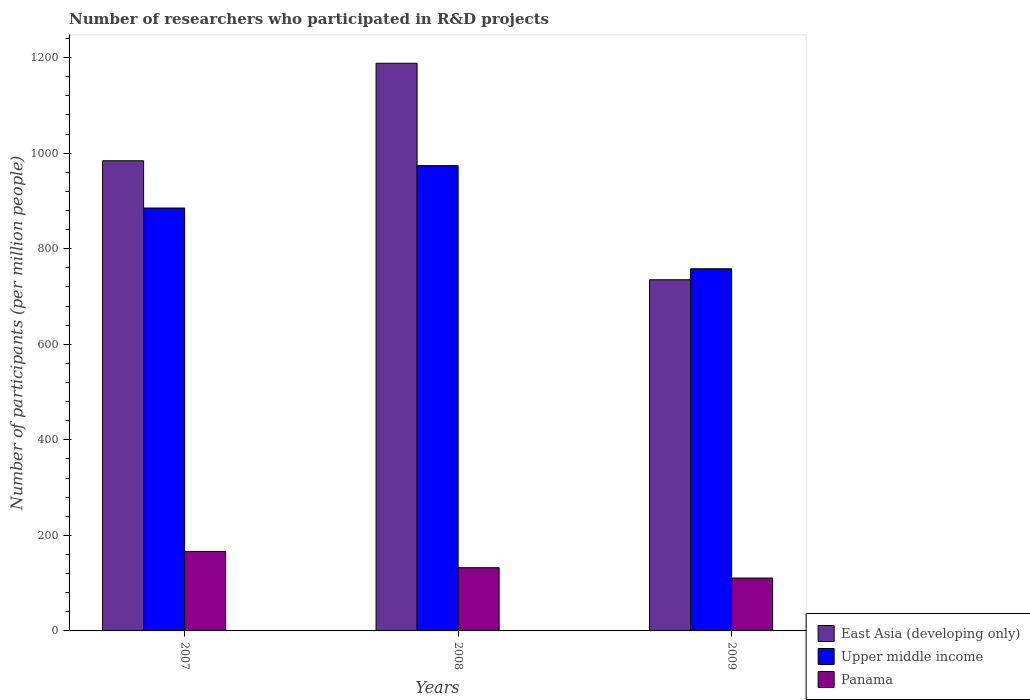How many different coloured bars are there?
Provide a succinct answer. 3. Are the number of bars per tick equal to the number of legend labels?
Your answer should be compact. Yes. Are the number of bars on each tick of the X-axis equal?
Make the answer very short. Yes. What is the label of the 3rd group of bars from the left?
Offer a very short reply. 2009. In how many cases, is the number of bars for a given year not equal to the number of legend labels?
Ensure brevity in your answer.  0. What is the number of researchers who participated in R&D projects in Panama in 2007?
Offer a very short reply. 166.36. Across all years, what is the maximum number of researchers who participated in R&D projects in Panama?
Your response must be concise. 166.36. Across all years, what is the minimum number of researchers who participated in R&D projects in Upper middle income?
Provide a short and direct response. 758.08. What is the total number of researchers who participated in R&D projects in Panama in the graph?
Provide a short and direct response. 409.38. What is the difference between the number of researchers who participated in R&D projects in East Asia (developing only) in 2007 and that in 2009?
Offer a very short reply. 249.1. What is the difference between the number of researchers who participated in R&D projects in East Asia (developing only) in 2007 and the number of researchers who participated in R&D projects in Panama in 2009?
Offer a very short reply. 873.46. What is the average number of researchers who participated in R&D projects in Panama per year?
Provide a short and direct response. 136.46. In the year 2008, what is the difference between the number of researchers who participated in R&D projects in East Asia (developing only) and number of researchers who participated in R&D projects in Panama?
Your response must be concise. 1055.9. In how many years, is the number of researchers who participated in R&D projects in East Asia (developing only) greater than 1200?
Your response must be concise. 0. What is the ratio of the number of researchers who participated in R&D projects in East Asia (developing only) in 2008 to that in 2009?
Your answer should be compact. 1.62. Is the number of researchers who participated in R&D projects in Upper middle income in 2007 less than that in 2008?
Offer a terse response. Yes. Is the difference between the number of researchers who participated in R&D projects in East Asia (developing only) in 2007 and 2008 greater than the difference between the number of researchers who participated in R&D projects in Panama in 2007 and 2008?
Ensure brevity in your answer.  No. What is the difference between the highest and the second highest number of researchers who participated in R&D projects in Panama?
Your answer should be compact. 34.02. What is the difference between the highest and the lowest number of researchers who participated in R&D projects in Panama?
Your response must be concise. 55.66. In how many years, is the number of researchers who participated in R&D projects in Panama greater than the average number of researchers who participated in R&D projects in Panama taken over all years?
Ensure brevity in your answer.  1. What does the 1st bar from the left in 2007 represents?
Offer a terse response. East Asia (developing only). What does the 1st bar from the right in 2009 represents?
Make the answer very short. Panama. How many years are there in the graph?
Ensure brevity in your answer.  3. What is the difference between two consecutive major ticks on the Y-axis?
Offer a terse response. 200. Are the values on the major ticks of Y-axis written in scientific E-notation?
Your response must be concise. No. Does the graph contain any zero values?
Provide a succinct answer. No. Does the graph contain grids?
Your response must be concise. No. How are the legend labels stacked?
Keep it short and to the point. Vertical. What is the title of the graph?
Your response must be concise. Number of researchers who participated in R&D projects. Does "Fiji" appear as one of the legend labels in the graph?
Your answer should be very brief. No. What is the label or title of the X-axis?
Your answer should be very brief. Years. What is the label or title of the Y-axis?
Your answer should be compact. Number of participants (per million people). What is the Number of participants (per million people) of East Asia (developing only) in 2007?
Ensure brevity in your answer.  984.15. What is the Number of participants (per million people) in Upper middle income in 2007?
Give a very brief answer. 885.24. What is the Number of participants (per million people) in Panama in 2007?
Give a very brief answer. 166.36. What is the Number of participants (per million people) of East Asia (developing only) in 2008?
Your answer should be very brief. 1188.24. What is the Number of participants (per million people) of Upper middle income in 2008?
Provide a short and direct response. 973.96. What is the Number of participants (per million people) of Panama in 2008?
Your answer should be compact. 132.34. What is the Number of participants (per million people) in East Asia (developing only) in 2009?
Ensure brevity in your answer.  735.05. What is the Number of participants (per million people) of Upper middle income in 2009?
Your response must be concise. 758.08. What is the Number of participants (per million people) of Panama in 2009?
Make the answer very short. 110.69. Across all years, what is the maximum Number of participants (per million people) in East Asia (developing only)?
Your answer should be compact. 1188.24. Across all years, what is the maximum Number of participants (per million people) of Upper middle income?
Offer a terse response. 973.96. Across all years, what is the maximum Number of participants (per million people) of Panama?
Offer a terse response. 166.36. Across all years, what is the minimum Number of participants (per million people) in East Asia (developing only)?
Offer a terse response. 735.05. Across all years, what is the minimum Number of participants (per million people) in Upper middle income?
Provide a succinct answer. 758.08. Across all years, what is the minimum Number of participants (per million people) in Panama?
Provide a succinct answer. 110.69. What is the total Number of participants (per million people) in East Asia (developing only) in the graph?
Your answer should be very brief. 2907.43. What is the total Number of participants (per million people) in Upper middle income in the graph?
Ensure brevity in your answer.  2617.28. What is the total Number of participants (per million people) in Panama in the graph?
Provide a succinct answer. 409.38. What is the difference between the Number of participants (per million people) in East Asia (developing only) in 2007 and that in 2008?
Make the answer very short. -204.09. What is the difference between the Number of participants (per million people) of Upper middle income in 2007 and that in 2008?
Your answer should be very brief. -88.72. What is the difference between the Number of participants (per million people) of Panama in 2007 and that in 2008?
Keep it short and to the point. 34.02. What is the difference between the Number of participants (per million people) in East Asia (developing only) in 2007 and that in 2009?
Provide a short and direct response. 249.1. What is the difference between the Number of participants (per million people) in Upper middle income in 2007 and that in 2009?
Offer a very short reply. 127.16. What is the difference between the Number of participants (per million people) of Panama in 2007 and that in 2009?
Offer a very short reply. 55.66. What is the difference between the Number of participants (per million people) of East Asia (developing only) in 2008 and that in 2009?
Keep it short and to the point. 453.19. What is the difference between the Number of participants (per million people) in Upper middle income in 2008 and that in 2009?
Offer a very short reply. 215.88. What is the difference between the Number of participants (per million people) of Panama in 2008 and that in 2009?
Offer a terse response. 21.64. What is the difference between the Number of participants (per million people) of East Asia (developing only) in 2007 and the Number of participants (per million people) of Upper middle income in 2008?
Your answer should be very brief. 10.19. What is the difference between the Number of participants (per million people) of East Asia (developing only) in 2007 and the Number of participants (per million people) of Panama in 2008?
Your answer should be compact. 851.81. What is the difference between the Number of participants (per million people) of Upper middle income in 2007 and the Number of participants (per million people) of Panama in 2008?
Keep it short and to the point. 752.91. What is the difference between the Number of participants (per million people) of East Asia (developing only) in 2007 and the Number of participants (per million people) of Upper middle income in 2009?
Your response must be concise. 226.07. What is the difference between the Number of participants (per million people) in East Asia (developing only) in 2007 and the Number of participants (per million people) in Panama in 2009?
Keep it short and to the point. 873.46. What is the difference between the Number of participants (per million people) of Upper middle income in 2007 and the Number of participants (per million people) of Panama in 2009?
Provide a short and direct response. 774.55. What is the difference between the Number of participants (per million people) of East Asia (developing only) in 2008 and the Number of participants (per million people) of Upper middle income in 2009?
Offer a very short reply. 430.16. What is the difference between the Number of participants (per million people) of East Asia (developing only) in 2008 and the Number of participants (per million people) of Panama in 2009?
Keep it short and to the point. 1077.54. What is the difference between the Number of participants (per million people) in Upper middle income in 2008 and the Number of participants (per million people) in Panama in 2009?
Your answer should be very brief. 863.27. What is the average Number of participants (per million people) in East Asia (developing only) per year?
Make the answer very short. 969.14. What is the average Number of participants (per million people) in Upper middle income per year?
Provide a short and direct response. 872.43. What is the average Number of participants (per million people) of Panama per year?
Make the answer very short. 136.46. In the year 2007, what is the difference between the Number of participants (per million people) of East Asia (developing only) and Number of participants (per million people) of Upper middle income?
Offer a very short reply. 98.91. In the year 2007, what is the difference between the Number of participants (per million people) of East Asia (developing only) and Number of participants (per million people) of Panama?
Your response must be concise. 817.79. In the year 2007, what is the difference between the Number of participants (per million people) of Upper middle income and Number of participants (per million people) of Panama?
Offer a terse response. 718.88. In the year 2008, what is the difference between the Number of participants (per million people) in East Asia (developing only) and Number of participants (per million people) in Upper middle income?
Your answer should be compact. 214.27. In the year 2008, what is the difference between the Number of participants (per million people) of East Asia (developing only) and Number of participants (per million people) of Panama?
Your answer should be very brief. 1055.9. In the year 2008, what is the difference between the Number of participants (per million people) in Upper middle income and Number of participants (per million people) in Panama?
Give a very brief answer. 841.63. In the year 2009, what is the difference between the Number of participants (per million people) in East Asia (developing only) and Number of participants (per million people) in Upper middle income?
Provide a short and direct response. -23.03. In the year 2009, what is the difference between the Number of participants (per million people) of East Asia (developing only) and Number of participants (per million people) of Panama?
Provide a succinct answer. 624.35. In the year 2009, what is the difference between the Number of participants (per million people) of Upper middle income and Number of participants (per million people) of Panama?
Offer a very short reply. 647.38. What is the ratio of the Number of participants (per million people) of East Asia (developing only) in 2007 to that in 2008?
Your answer should be compact. 0.83. What is the ratio of the Number of participants (per million people) of Upper middle income in 2007 to that in 2008?
Provide a succinct answer. 0.91. What is the ratio of the Number of participants (per million people) in Panama in 2007 to that in 2008?
Your answer should be very brief. 1.26. What is the ratio of the Number of participants (per million people) in East Asia (developing only) in 2007 to that in 2009?
Make the answer very short. 1.34. What is the ratio of the Number of participants (per million people) in Upper middle income in 2007 to that in 2009?
Provide a short and direct response. 1.17. What is the ratio of the Number of participants (per million people) in Panama in 2007 to that in 2009?
Your response must be concise. 1.5. What is the ratio of the Number of participants (per million people) in East Asia (developing only) in 2008 to that in 2009?
Provide a succinct answer. 1.62. What is the ratio of the Number of participants (per million people) in Upper middle income in 2008 to that in 2009?
Your answer should be compact. 1.28. What is the ratio of the Number of participants (per million people) of Panama in 2008 to that in 2009?
Make the answer very short. 1.2. What is the difference between the highest and the second highest Number of participants (per million people) of East Asia (developing only)?
Make the answer very short. 204.09. What is the difference between the highest and the second highest Number of participants (per million people) of Upper middle income?
Give a very brief answer. 88.72. What is the difference between the highest and the second highest Number of participants (per million people) of Panama?
Make the answer very short. 34.02. What is the difference between the highest and the lowest Number of participants (per million people) of East Asia (developing only)?
Make the answer very short. 453.19. What is the difference between the highest and the lowest Number of participants (per million people) in Upper middle income?
Keep it short and to the point. 215.88. What is the difference between the highest and the lowest Number of participants (per million people) in Panama?
Offer a terse response. 55.66. 